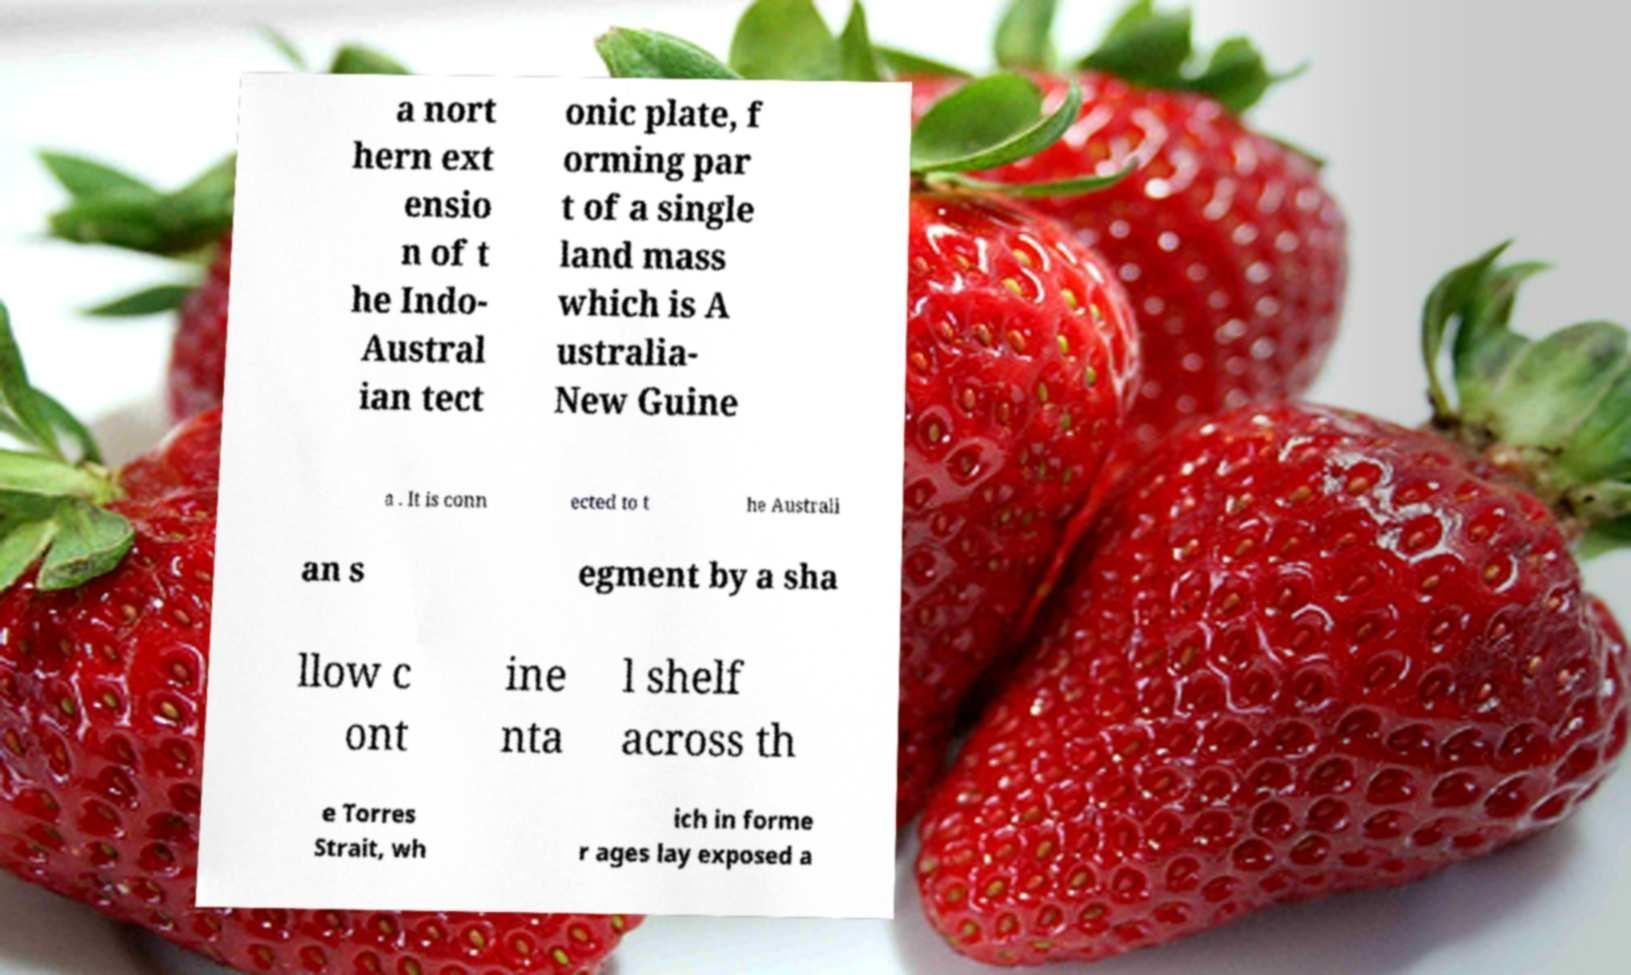Please read and relay the text visible in this image. What does it say? a nort hern ext ensio n of t he Indo- Austral ian tect onic plate, f orming par t of a single land mass which is A ustralia- New Guine a . It is conn ected to t he Australi an s egment by a sha llow c ont ine nta l shelf across th e Torres Strait, wh ich in forme r ages lay exposed a 